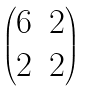Convert formula to latex. <formula><loc_0><loc_0><loc_500><loc_500>\begin{pmatrix} 6 & 2 \\ 2 & 2 \\ \end{pmatrix}</formula> 